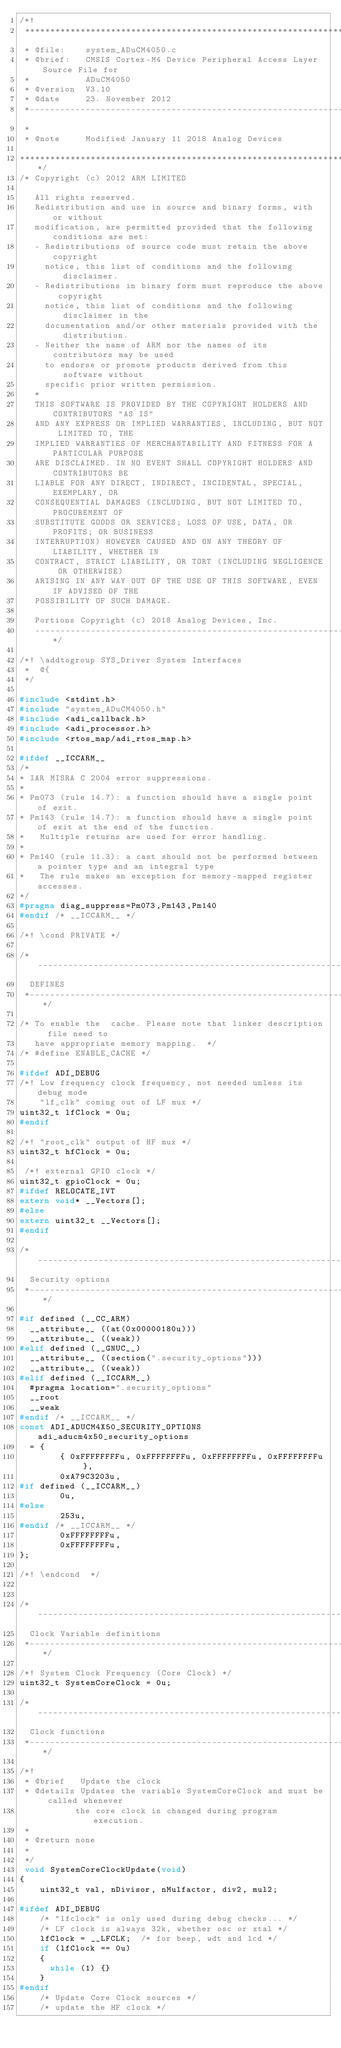Convert code to text. <code><loc_0><loc_0><loc_500><loc_500><_C_>/*!
 *****************************************************************************
 * @file:    system_ADuCM4050.c
 * @brief:   CMSIS Cortex-M4 Device Peripheral Access Layer Source File for
 *           ADuCM4050
 * @version  V3.10
 * @date     23. November 2012
 *-----------------------------------------------------------------------------
 *
 * @note     Modified January 11 2018 Analog Devices 

******************************************************************************/
/* Copyright (c) 2012 ARM LIMITED

   All rights reserved.
   Redistribution and use in source and binary forms, with or without
   modification, are permitted provided that the following conditions are met:
   - Redistributions of source code must retain the above copyright
     notice, this list of conditions and the following disclaimer.
   - Redistributions in binary form must reproduce the above copyright
     notice, this list of conditions and the following disclaimer in the
     documentation and/or other materials provided with the distribution.
   - Neither the name of ARM nor the names of its contributors may be used
     to endorse or promote products derived from this software without
     specific prior written permission.
   *
   THIS SOFTWARE IS PROVIDED BY THE COPYRIGHT HOLDERS AND CONTRIBUTORS "AS IS"
   AND ANY EXPRESS OR IMPLIED WARRANTIES, INCLUDING, BUT NOT LIMITED TO, THE
   IMPLIED WARRANTIES OF MERCHANTABILITY AND FITNESS FOR A PARTICULAR PURPOSE
   ARE DISCLAIMED. IN NO EVENT SHALL COPYRIGHT HOLDERS AND CONTRIBUTORS BE
   LIABLE FOR ANY DIRECT, INDIRECT, INCIDENTAL, SPECIAL, EXEMPLARY, OR
   CONSEQUENTIAL DAMAGES (INCLUDING, BUT NOT LIMITED TO, PROCUREMENT OF
   SUBSTITUTE GOODS OR SERVICES; LOSS OF USE, DATA, OR PROFITS; OR BUSINESS
   INTERRUPTION) HOWEVER CAUSED AND ON ANY THEORY OF LIABILITY, WHETHER IN
   CONTRACT, STRICT LIABILITY, OR TORT (INCLUDING NEGLIGENCE OR OTHERWISE)
   ARISING IN ANY WAY OUT OF THE USE OF THIS SOFTWARE, EVEN IF ADVISED OF THE
   POSSIBILITY OF SUCH DAMAGE.

   Portions Copyright (c) 2018 Analog Devices, Inc.
   ---------------------------------------------------------------------------*/

/*! \addtogroup SYS_Driver System Interfaces
 *  @{
 */

#include <stdint.h>
#include "system_ADuCM4050.h"
#include <adi_callback.h>
#include <adi_processor.h>
#include <rtos_map/adi_rtos_map.h>

#ifdef __ICCARM__
/*
* IAR MISRA C 2004 error suppressions.
*
* Pm073 (rule 14.7): a function should have a single point of exit.
* Pm143 (rule 14.7): a function should have a single point of exit at the end of the function.
*   Multiple returns are used for error handling.
*
* Pm140 (rule 11.3): a cast should not be performed between a pointer type and an integral type
*   The rule makes an exception for memory-mapped register accesses.
*/
#pragma diag_suppress=Pm073,Pm143,Pm140
#endif /* __ICCARM__ */

/*! \cond PRIVATE */

/*----------------------------------------------------------------------------
  DEFINES
 *----------------------------------------------------------------------------*/

/* To enable the  cache. Please note that linker description  file need to 
   have appropriate memory mapping.  */
/* #define ENABLE_CACHE */

#ifdef ADI_DEBUG
/*! Low frequency clock frequency, not needed unless its debug mode 
    "lf_clk" coming out of LF mux */
uint32_t lfClock = 0u;
#endif

/*! "root_clk" output of HF mux */
uint32_t hfClock = 0u;  

 /*! external GPIO clock */  
uint32_t gpioClock = 0u;
#ifdef RELOCATE_IVT
extern void* __Vectors[];
#else
extern uint32_t __Vectors[];
#endif

/*----------------------------------------------------------------------------
  Security options
 *----------------------------------------------------------------------------*/

#if defined (__CC_ARM)
  __attribute__ ((at(0x00000180u)))
  __attribute__ ((weak))
#elif defined (__GNUC__)
  __attribute__ ((section(".security_options")))
  __attribute__ ((weak))
#elif defined (__ICCARM__)
  #pragma location=".security_options"
  __root
  __weak
#endif /* __ICCARM__ */
const ADI_ADUCM4X50_SECURITY_OPTIONS adi_aducm4x50_security_options
  = {
        { 0xFFFFFFFFu, 0xFFFFFFFFu, 0xFFFFFFFFu, 0xFFFFFFFFu },
        0xA79C3203u,
#if defined (__ICCARM__)
        0u,
#else
        253u,
#endif /* __ICCARM__ */
        0xFFFFFFFFu,
        0xFFFFFFFFu,
};

/*! \endcond  */


/*----------------------------------------------------------------------------
  Clock Variable definitions
 *----------------------------------------------------------------------------*/

/*! System Clock Frequency (Core Clock) */
uint32_t SystemCoreClock = 0u;

/*----------------------------------------------------------------------------
  Clock functions
 *----------------------------------------------------------------------------*/

/*!
 * @brief   Update the clock
 * @details Updates the variable SystemCoreClock and must be called whenever
           the core clock is changed during program execution.
 *
 * @return none
 *
 */
 void SystemCoreClockUpdate(void)
{
    uint32_t val, nDivisor, nMulfactor, div2, mul2;

#ifdef ADI_DEBUG
    /* "lfclock" is only used during debug checks... */
    /* LF clock is always 32k, whether osc or xtal */
    lfClock = __LFCLK;  /* for beep, wdt and lcd */
    if (lfClock == 0u)
    {
      while (1) {}
    }
#endif
    /* Update Core Clock sources */
    /* update the HF clock */</code> 